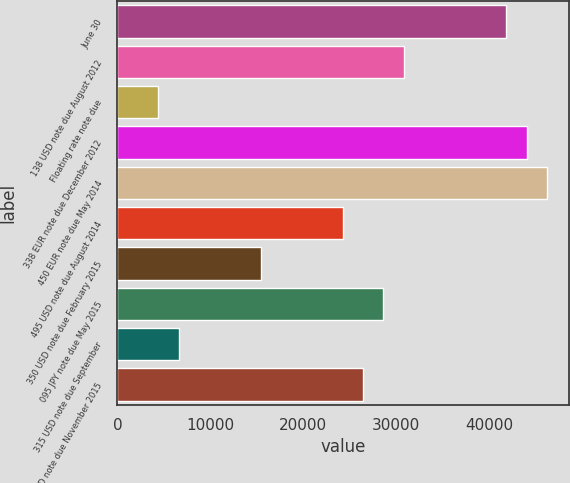Convert chart. <chart><loc_0><loc_0><loc_500><loc_500><bar_chart><fcel>June 30<fcel>138 USD note due August 2012<fcel>Floating rate note due<fcel>338 EUR note due December 2012<fcel>450 EUR note due May 2014<fcel>495 USD note due August 2014<fcel>350 USD note due February 2015<fcel>095 JPY note due May 2015<fcel>315 USD note due September<fcel>180 USD note due November 2015<nl><fcel>41859.6<fcel>30844.8<fcel>4409.32<fcel>44062.6<fcel>46265.6<fcel>24236<fcel>15424.1<fcel>28641.9<fcel>6612.28<fcel>26438.9<nl></chart> 